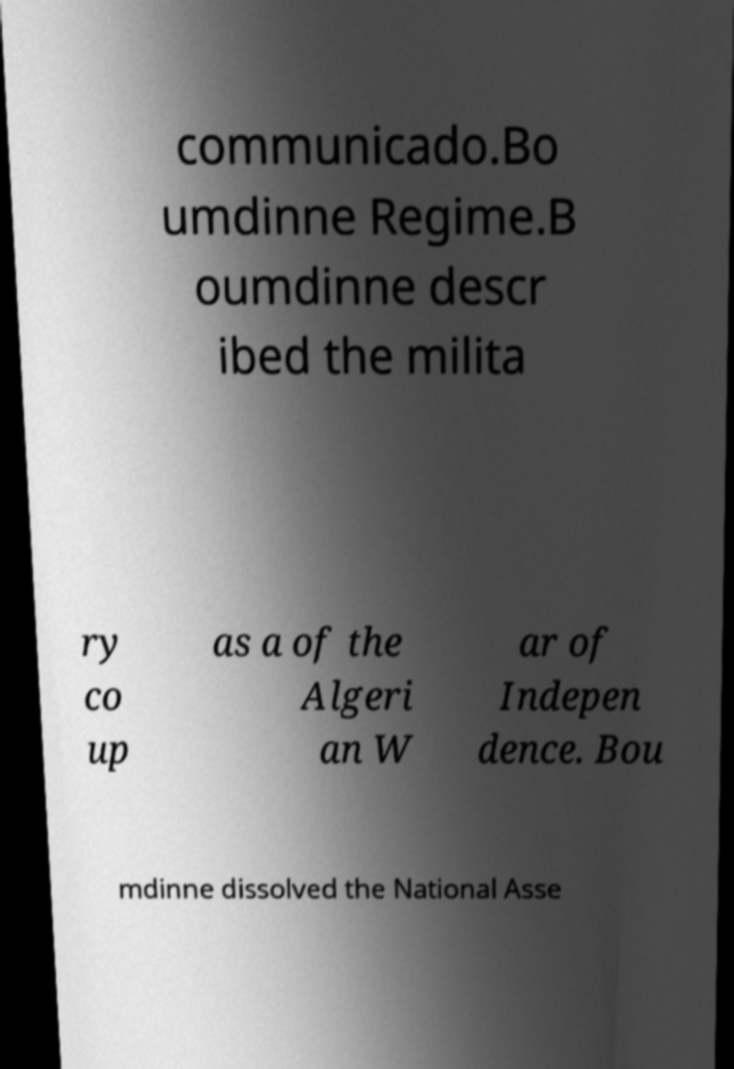There's text embedded in this image that I need extracted. Can you transcribe it verbatim? communicado.Bo umdinne Regime.B oumdinne descr ibed the milita ry co up as a of the Algeri an W ar of Indepen dence. Bou mdinne dissolved the National Asse 